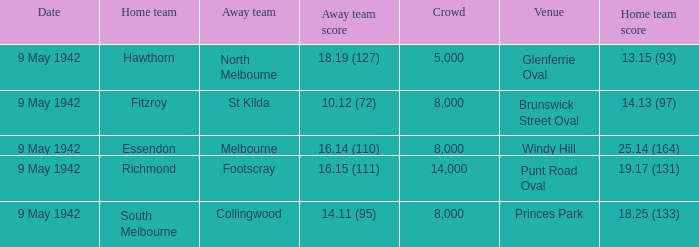How many people attended the game with the home team scoring 18.25 (133)? 1.0. 